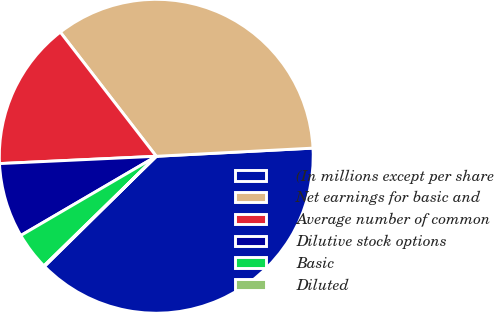<chart> <loc_0><loc_0><loc_500><loc_500><pie_chart><fcel>(In millions except per share<fcel>Net earnings for basic and<fcel>Average number of common<fcel>Dilutive stock options<fcel>Basic<fcel>Diluted<nl><fcel>38.45%<fcel>34.65%<fcel>15.27%<fcel>7.68%<fcel>3.88%<fcel>0.08%<nl></chart> 